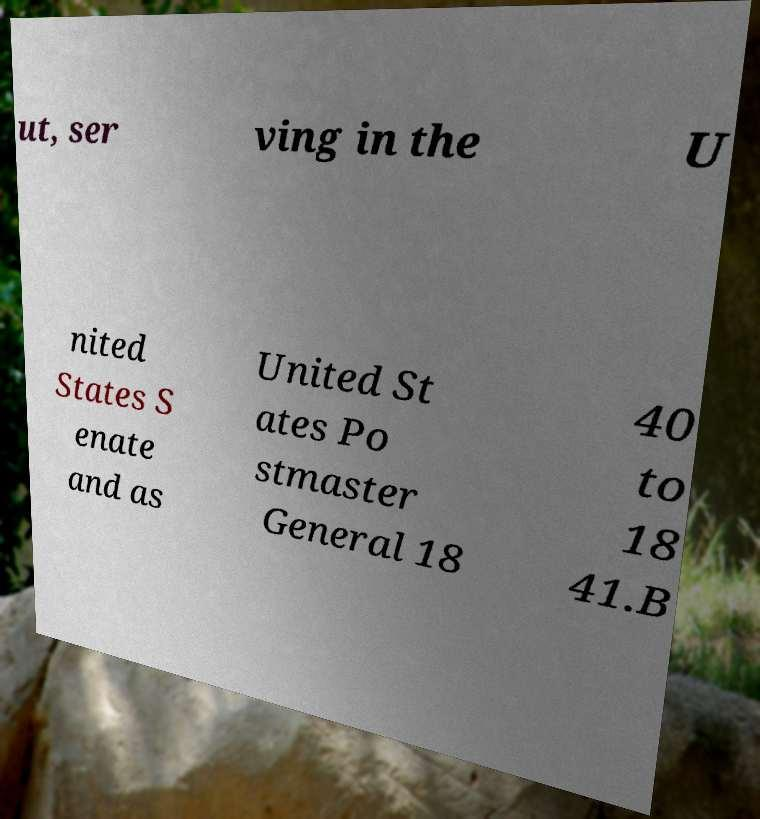Can you read and provide the text displayed in the image?This photo seems to have some interesting text. Can you extract and type it out for me? ut, ser ving in the U nited States S enate and as United St ates Po stmaster General 18 40 to 18 41.B 